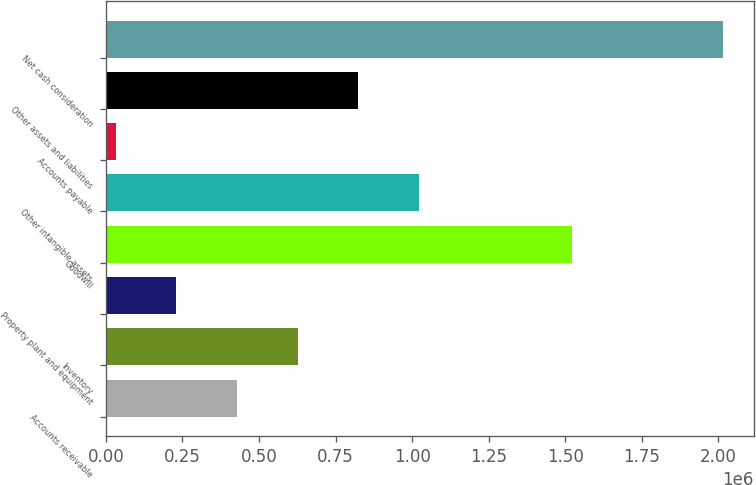Convert chart. <chart><loc_0><loc_0><loc_500><loc_500><bar_chart><fcel>Accounts receivable<fcel>Inventory<fcel>Property plant and equipment<fcel>Goodwill<fcel>Other intangible assets<fcel>Accounts payable<fcel>Other assets and liabilities<fcel>Net cash consideration<nl><fcel>428320<fcel>626608<fcel>230032<fcel>1.52335e+06<fcel>1.02318e+06<fcel>31744<fcel>824896<fcel>2.01462e+06<nl></chart> 